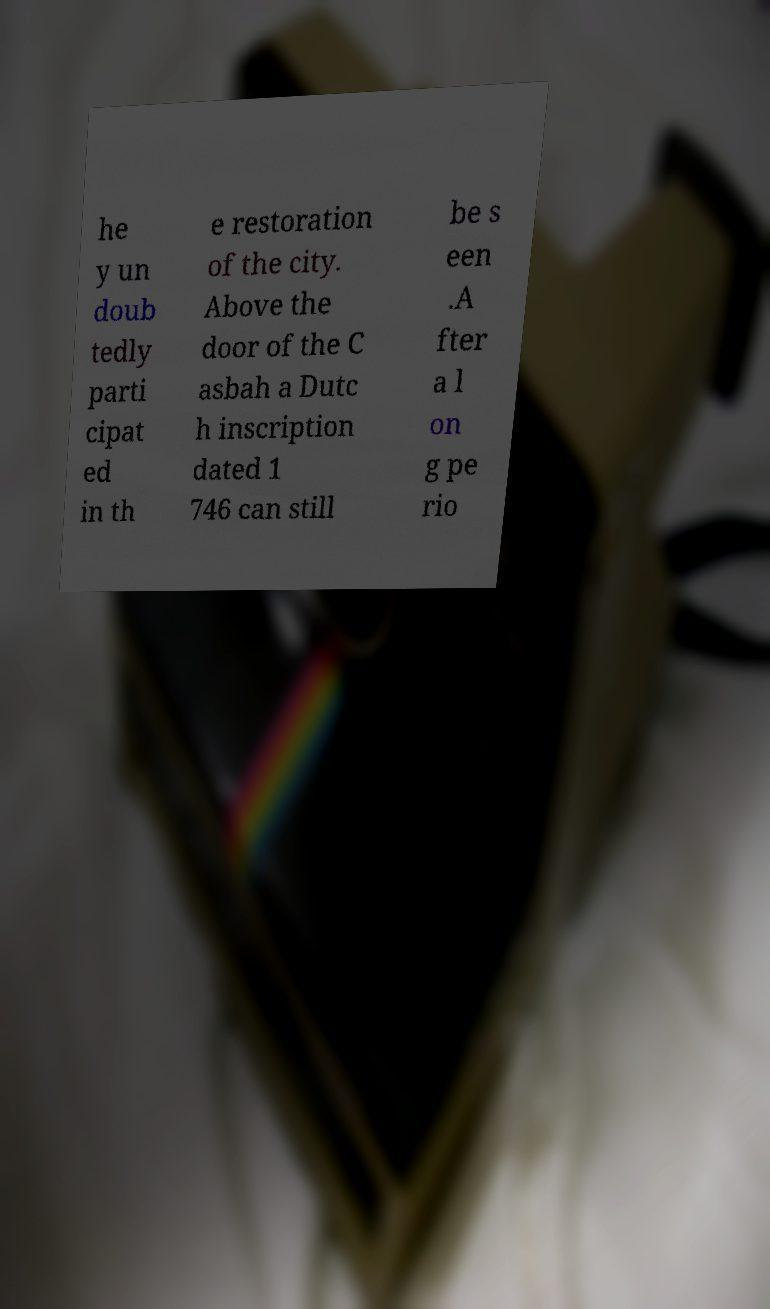There's text embedded in this image that I need extracted. Can you transcribe it verbatim? he y un doub tedly parti cipat ed in th e restoration of the city. Above the door of the C asbah a Dutc h inscription dated 1 746 can still be s een .A fter a l on g pe rio 